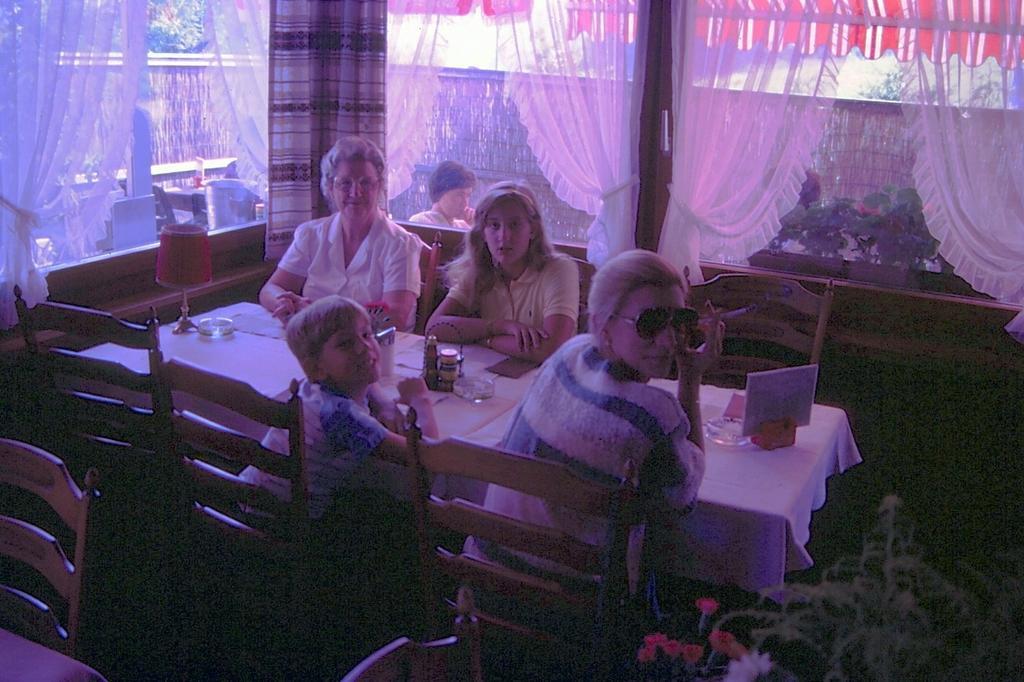Please provide a concise description of this image. As we can see in the image there are curtains, windows, wall, few people sitting on chairs and table. On table there is a white color cloth. 